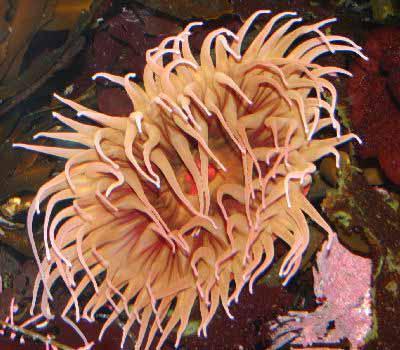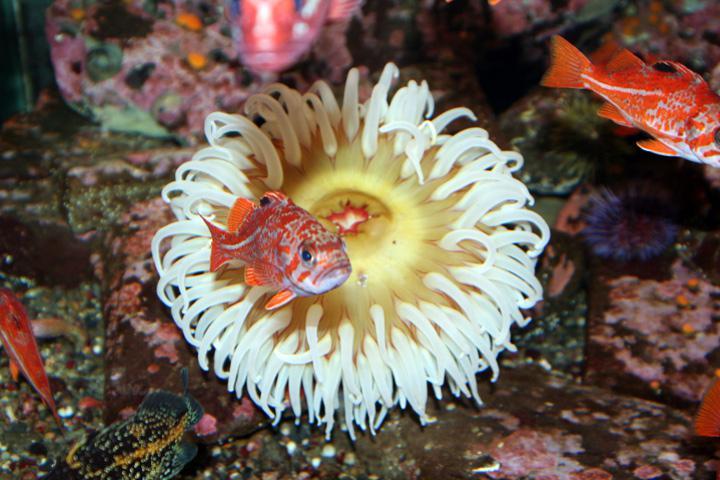The first image is the image on the left, the second image is the image on the right. Analyze the images presented: Is the assertion "In one image, there is at least one fish swimming in or near the sea anemone" valid? Answer yes or no. Yes. The first image is the image on the left, the second image is the image on the right. Analyze the images presented: Is the assertion "there are 2 fish swimming near the anenome" valid? Answer yes or no. Yes. 